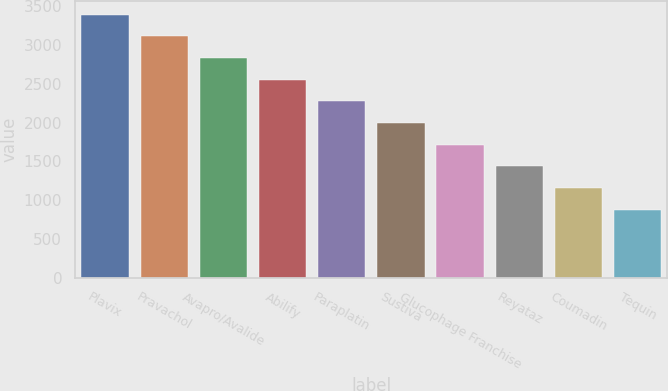Convert chart to OTSL. <chart><loc_0><loc_0><loc_500><loc_500><bar_chart><fcel>Plavix<fcel>Pravachol<fcel>Avapro/Avalide<fcel>Abilify<fcel>Paraplatin<fcel>Sustiva<fcel>Glucophage Franchise<fcel>Reyataz<fcel>Coumadin<fcel>Tequin<nl><fcel>3392.8<fcel>3112.9<fcel>2833<fcel>2553.1<fcel>2273.2<fcel>1993.3<fcel>1713.4<fcel>1433.5<fcel>1153.6<fcel>873.7<nl></chart> 